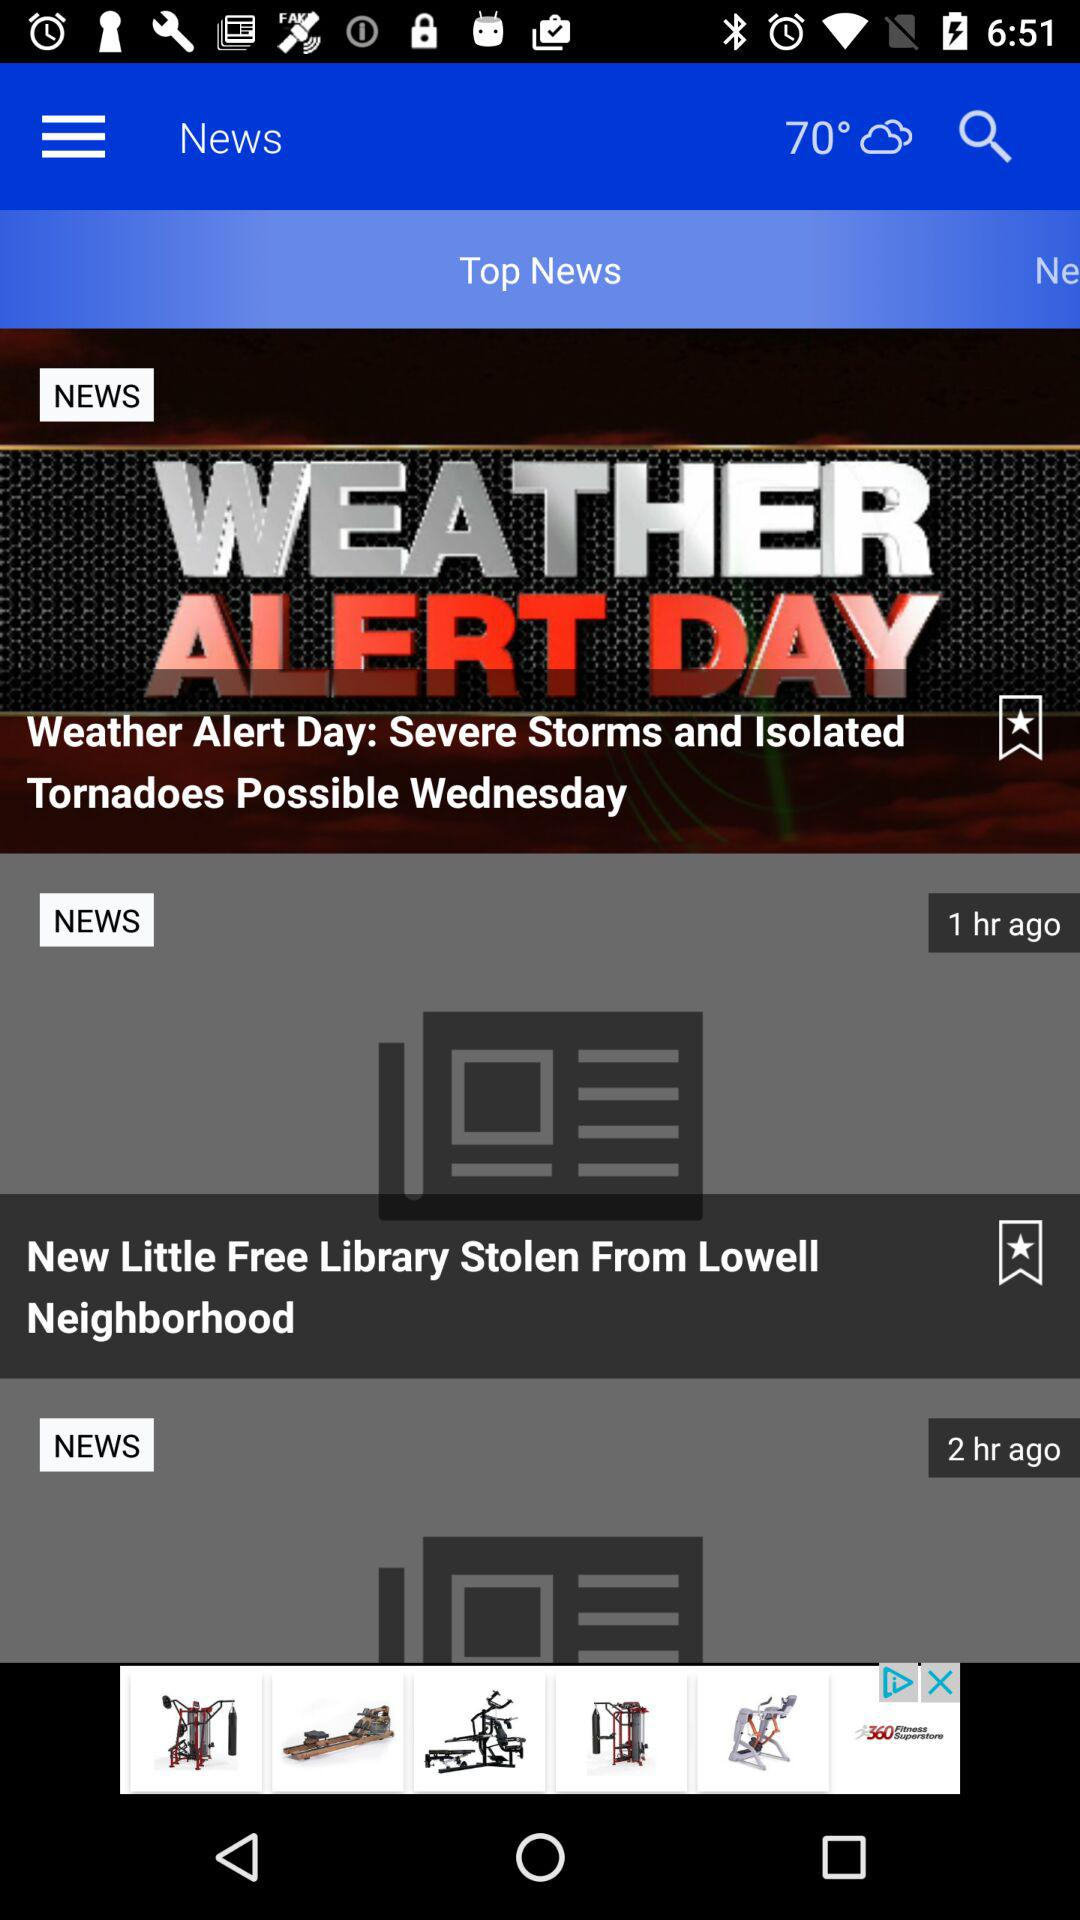How many news articles are there with a star?
Answer the question using a single word or phrase. 2 